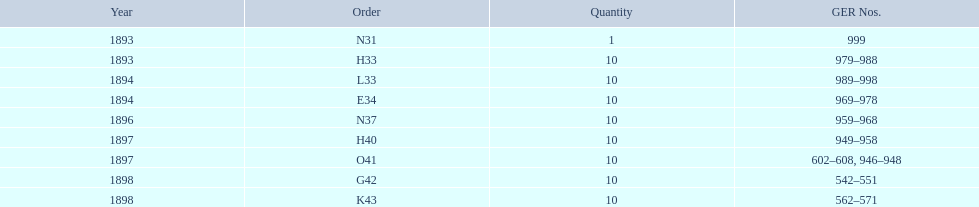What is the total number of locomotives made during this time? 81. 